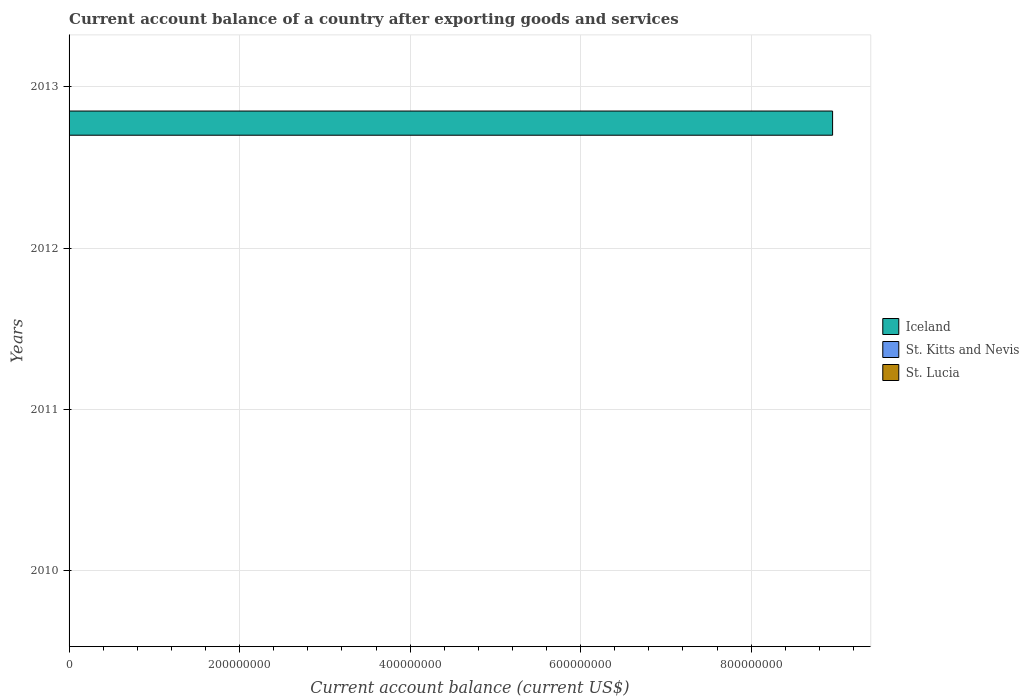How many different coloured bars are there?
Offer a terse response. 1. Are the number of bars per tick equal to the number of legend labels?
Your answer should be compact. No. How many bars are there on the 2nd tick from the bottom?
Provide a short and direct response. 0. What is the label of the 1st group of bars from the top?
Give a very brief answer. 2013. What is the account balance in St. Kitts and Nevis in 2011?
Offer a very short reply. 0. Across all years, what is the maximum account balance in Iceland?
Offer a terse response. 8.96e+08. In which year was the account balance in Iceland maximum?
Make the answer very short. 2013. What is the difference between the account balance in Iceland in 2010 and the account balance in St. Kitts and Nevis in 2011?
Provide a short and direct response. 0. In how many years, is the account balance in Iceland greater than the average account balance in Iceland taken over all years?
Give a very brief answer. 1. How many bars are there?
Give a very brief answer. 1. Are all the bars in the graph horizontal?
Ensure brevity in your answer.  Yes. What is the difference between two consecutive major ticks on the X-axis?
Make the answer very short. 2.00e+08. Does the graph contain grids?
Keep it short and to the point. Yes. What is the title of the graph?
Ensure brevity in your answer.  Current account balance of a country after exporting goods and services. Does "Monaco" appear as one of the legend labels in the graph?
Keep it short and to the point. No. What is the label or title of the X-axis?
Offer a terse response. Current account balance (current US$). What is the Current account balance (current US$) in Iceland in 2010?
Keep it short and to the point. 0. What is the Current account balance (current US$) of St. Kitts and Nevis in 2010?
Offer a very short reply. 0. What is the Current account balance (current US$) in St. Lucia in 2010?
Your response must be concise. 0. What is the Current account balance (current US$) of Iceland in 2011?
Offer a terse response. 0. What is the Current account balance (current US$) in St. Kitts and Nevis in 2011?
Give a very brief answer. 0. What is the Current account balance (current US$) in Iceland in 2012?
Provide a short and direct response. 0. What is the Current account balance (current US$) in St. Lucia in 2012?
Make the answer very short. 0. What is the Current account balance (current US$) in Iceland in 2013?
Keep it short and to the point. 8.96e+08. Across all years, what is the maximum Current account balance (current US$) in Iceland?
Offer a terse response. 8.96e+08. What is the total Current account balance (current US$) in Iceland in the graph?
Your answer should be very brief. 8.96e+08. What is the total Current account balance (current US$) of St. Kitts and Nevis in the graph?
Provide a short and direct response. 0. What is the average Current account balance (current US$) in Iceland per year?
Your answer should be compact. 2.24e+08. What is the average Current account balance (current US$) in St. Kitts and Nevis per year?
Make the answer very short. 0. What is the average Current account balance (current US$) of St. Lucia per year?
Offer a very short reply. 0. What is the difference between the highest and the lowest Current account balance (current US$) in Iceland?
Offer a terse response. 8.96e+08. 